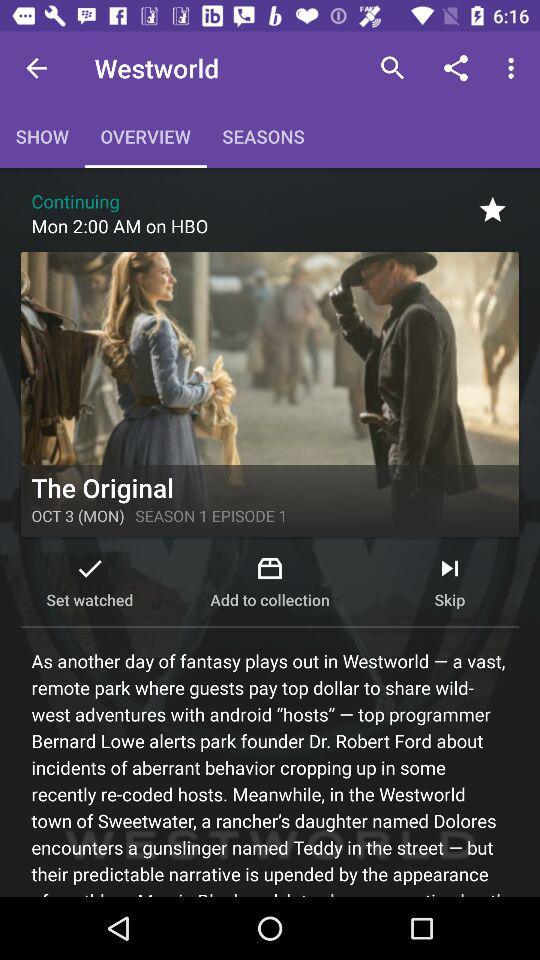What episode is given? The given episode is 1. 